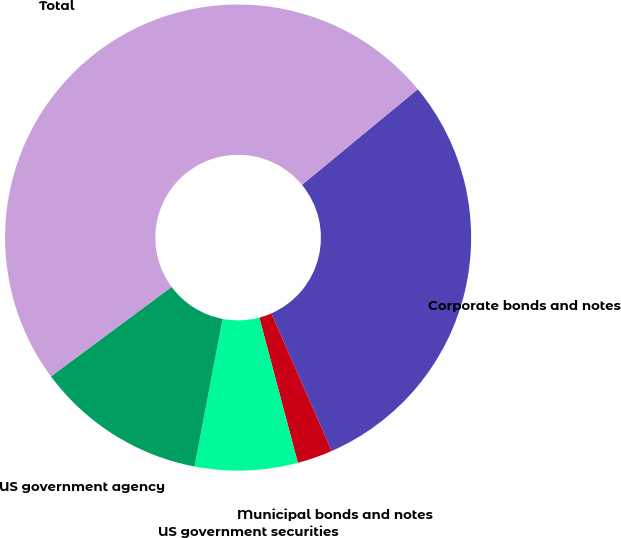Convert chart. <chart><loc_0><loc_0><loc_500><loc_500><pie_chart><fcel>Corporate bonds and notes<fcel>Municipal bonds and notes<fcel>US government securities<fcel>US government agency<fcel>Total<nl><fcel>29.41%<fcel>2.45%<fcel>7.12%<fcel>11.85%<fcel>49.17%<nl></chart> 